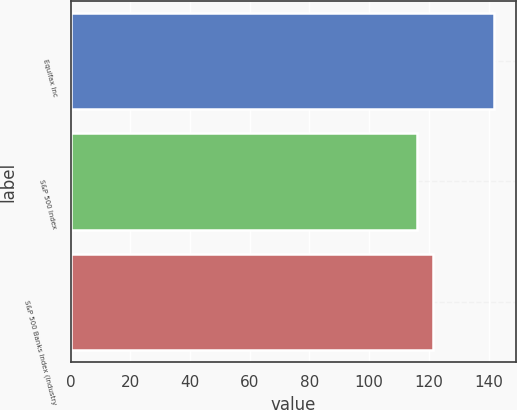<chart> <loc_0><loc_0><loc_500><loc_500><bar_chart><fcel>Equifax Inc<fcel>S&P 500 Index<fcel>S&P 500 Banks Index (Industry<nl><fcel>141.91<fcel>116<fcel>121.19<nl></chart> 